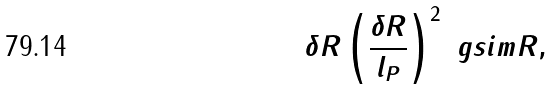<formula> <loc_0><loc_0><loc_500><loc_500>\delta R \left ( \frac { \delta R } { l _ { P } } \right ) ^ { 2 } \ g s i m R ,</formula> 